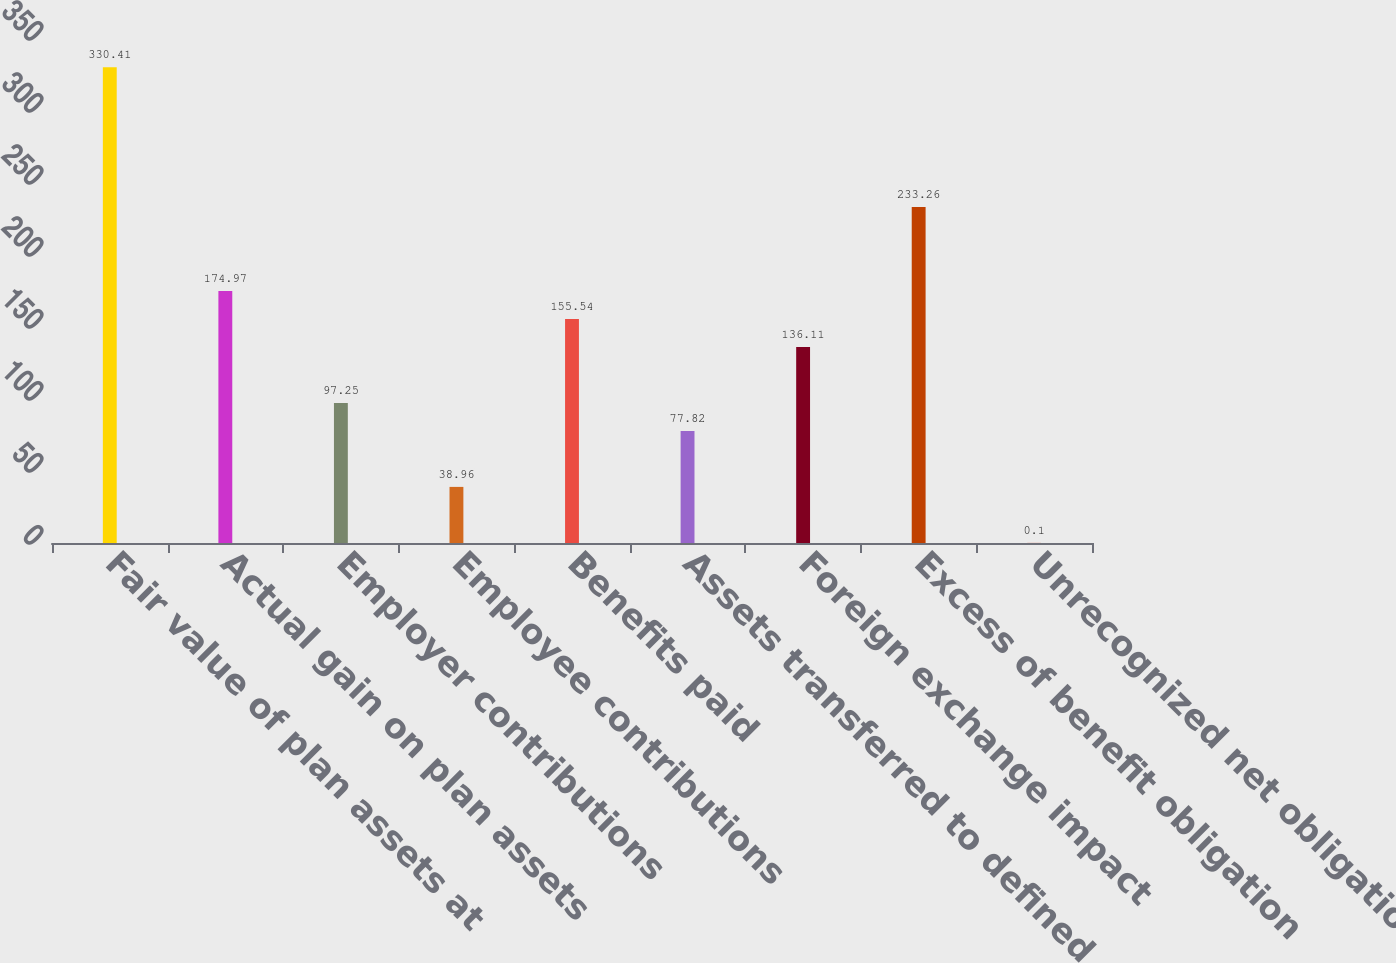<chart> <loc_0><loc_0><loc_500><loc_500><bar_chart><fcel>Fair value of plan assets at<fcel>Actual gain on plan assets<fcel>Employer contributions<fcel>Employee contributions<fcel>Benefits paid<fcel>Assets transferred to defined<fcel>Foreign exchange impact<fcel>Excess of benefit obligation<fcel>Unrecognized net obligation<nl><fcel>330.41<fcel>174.97<fcel>97.25<fcel>38.96<fcel>155.54<fcel>77.82<fcel>136.11<fcel>233.26<fcel>0.1<nl></chart> 